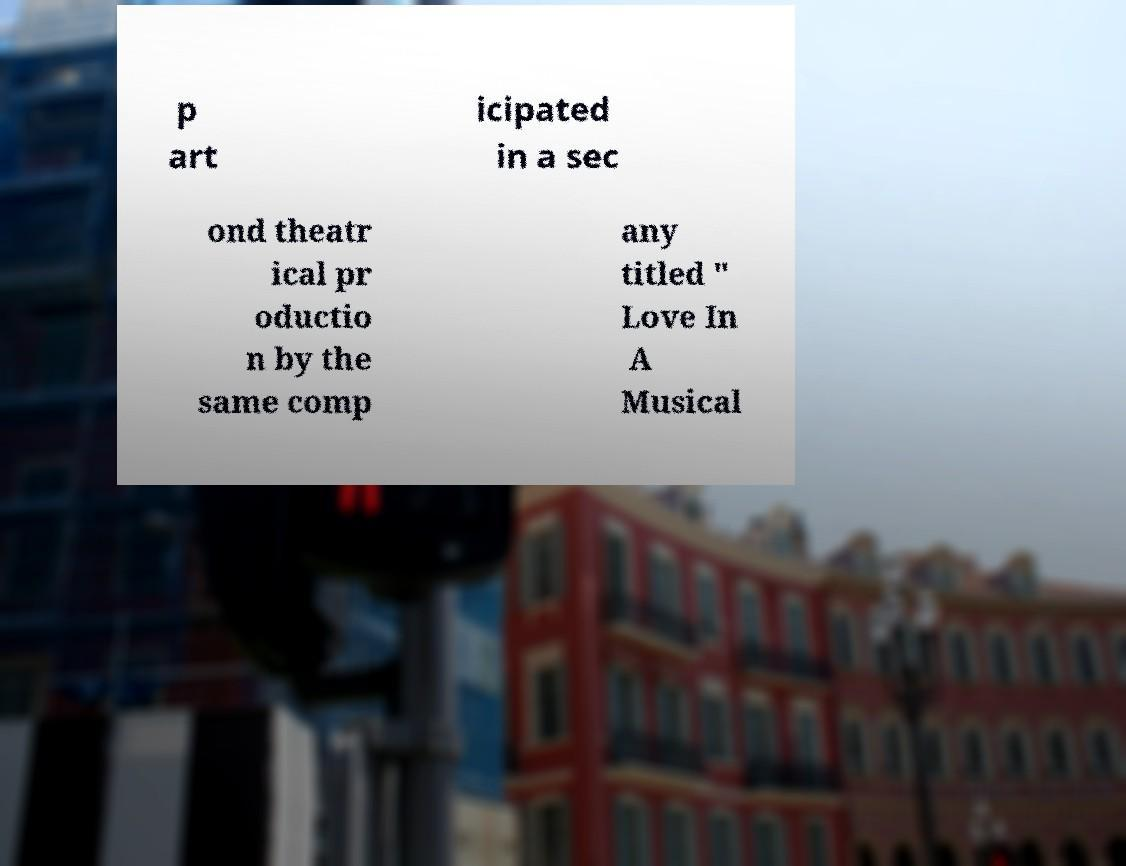Could you assist in decoding the text presented in this image and type it out clearly? p art icipated in a sec ond theatr ical pr oductio n by the same comp any titled " Love In A Musical 